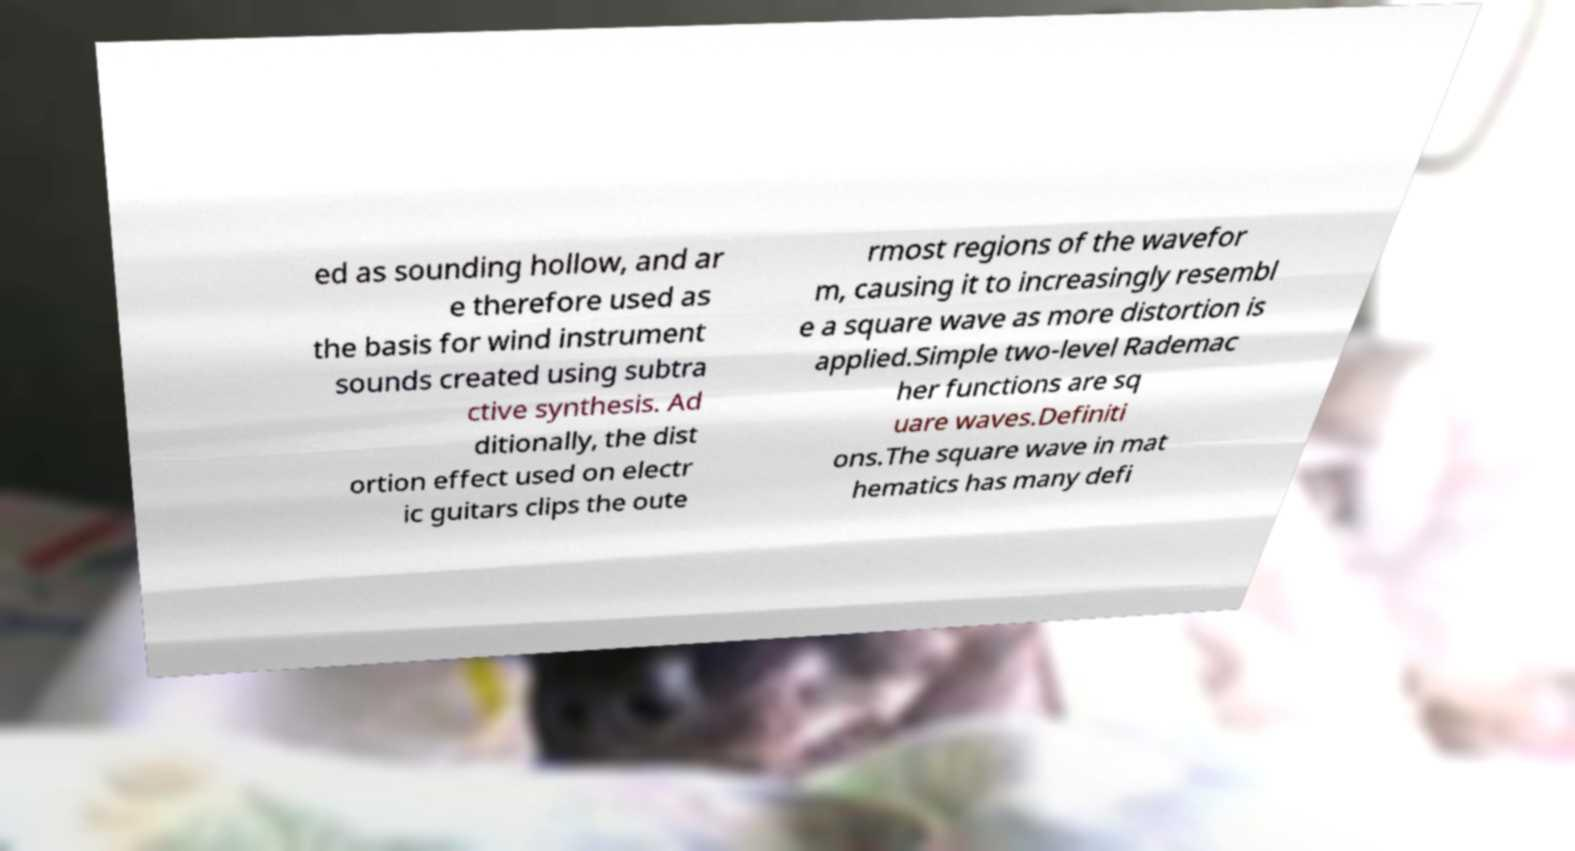Can you accurately transcribe the text from the provided image for me? ed as sounding hollow, and ar e therefore used as the basis for wind instrument sounds created using subtra ctive synthesis. Ad ditionally, the dist ortion effect used on electr ic guitars clips the oute rmost regions of the wavefor m, causing it to increasingly resembl e a square wave as more distortion is applied.Simple two-level Rademac her functions are sq uare waves.Definiti ons.The square wave in mat hematics has many defi 